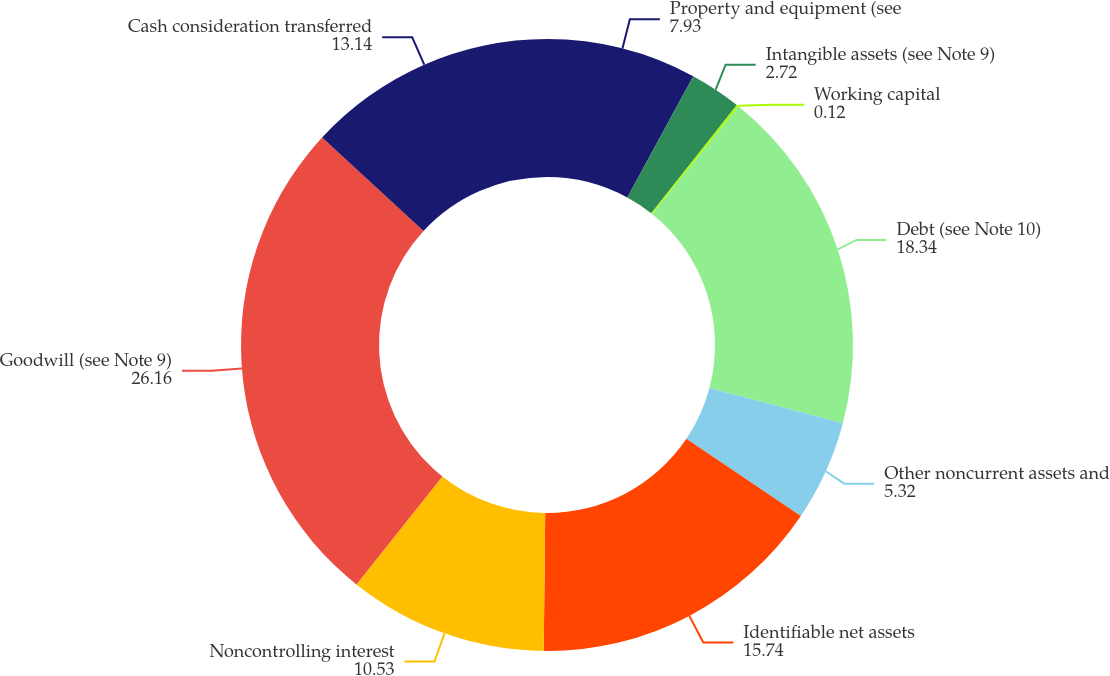Convert chart. <chart><loc_0><loc_0><loc_500><loc_500><pie_chart><fcel>Property and equipment (see<fcel>Intangible assets (see Note 9)<fcel>Working capital<fcel>Debt (see Note 10)<fcel>Other noncurrent assets and<fcel>Identifiable net assets<fcel>Noncontrolling interest<fcel>Goodwill (see Note 9)<fcel>Cash consideration transferred<nl><fcel>7.93%<fcel>2.72%<fcel>0.12%<fcel>18.34%<fcel>5.32%<fcel>15.74%<fcel>10.53%<fcel>26.16%<fcel>13.14%<nl></chart> 